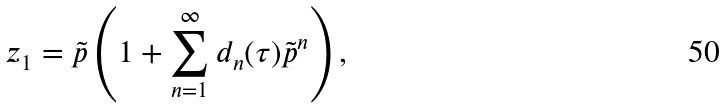<formula> <loc_0><loc_0><loc_500><loc_500>z _ { 1 } = \tilde { p } \left ( 1 + \sum _ { n = 1 } ^ { \infty } d _ { n } ( \tau ) \tilde { p } ^ { n } \right ) ,</formula> 